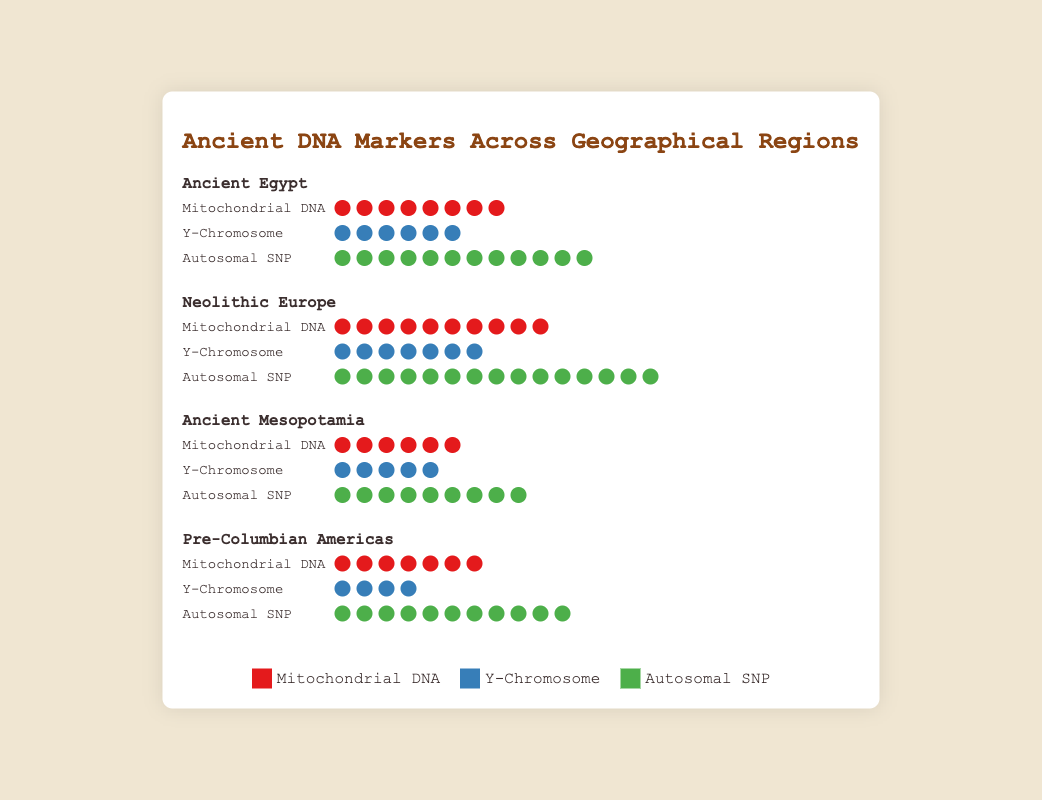What are the three types of genetic markers displayed in the figure? The figure legend shows three types of genetic markers, each represented by a different color: red for Mitochondrial DNA, blue for Y-Chromosome, and green for Autosomal SNP.
Answer: Mitochondrial DNA, Y-Chromosome, Autosomal SNP Which region has the highest number of Autosomal SNP markers? By visually examining the number of green circles (Autosomal SNP markers) in the figure, Neolithic Europe has the most with a total count of 15 green circles.
Answer: Neolithic Europe What is the total count of genetic markers found in Ancient Egypt? Adding up the counts of each type of marker in Ancient Egypt: 8 (Mitochondrial DNA) + 6 (Y-Chromosome) + 12 (Autosomal SNP) = 26
Answer: 26 How does the number of Y-Chromosome markers in Pre-Columbian Americas compare to those in Neolithic Europe? Neolithic Europe has 7 blue circles (Y-Chromosome markers), whereas Pre-Columbian Americas has 4 blue circles. Therefore, Neolithic Europe has more Y-Chromosome markers than Pre-Columbian Americas.
Answer: Neolithic Europe has more Among all regions, which has the least number of Mitochondrial DNA markers, and how many does it have? By comparing the red circles (Mitochondrial DNA markers) across all regions, Ancient Mesopotamia has the least with a total of 6 red circles.
Answer: Ancient Mesopotamia, 6 What are the counts of the Y-Chromosome markers for all regions combined? Adding up the counts of Y-Chromosome markers from each region: 6 (Ancient Egypt) + 7 (Neolithic Europe) + 5 (Ancient Mesopotamia) + 4 (Pre-Columbian Americas) = 22
Answer: 22 Which region has the most balanced representation of all three types of genetic markers? Comparing the counts of each marker type in the regions, Ancient Egypt has counts roughly similar: 8 (Mitochondrial DNA), 6 (Y-Chromosome), and 12 (Autosomal SNP), indicating a more balanced representation compared to other regions.
Answer: Ancient Egypt 